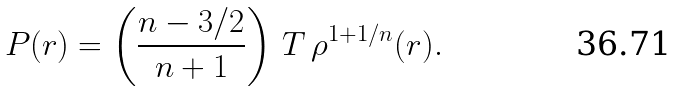Convert formula to latex. <formula><loc_0><loc_0><loc_500><loc_500>P ( r ) = \left ( \frac { n - 3 / 2 } { n + 1 } \right ) \, T \, \rho ^ { 1 + 1 / n } ( r ) .</formula> 